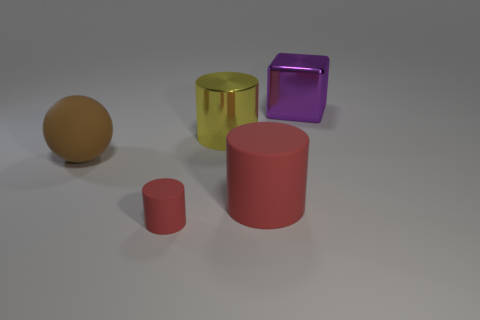Subtract all big cylinders. How many cylinders are left? 1 Add 4 small purple objects. How many objects exist? 9 Subtract all yellow cylinders. How many cylinders are left? 2 Subtract 2 cylinders. How many cylinders are left? 1 Subtract all cyan balls. How many red cylinders are left? 2 Add 4 red rubber things. How many red rubber things exist? 6 Subtract 0 gray cylinders. How many objects are left? 5 Subtract all spheres. How many objects are left? 4 Subtract all brown cylinders. Subtract all gray spheres. How many cylinders are left? 3 Subtract all big yellow metal objects. Subtract all small rubber objects. How many objects are left? 3 